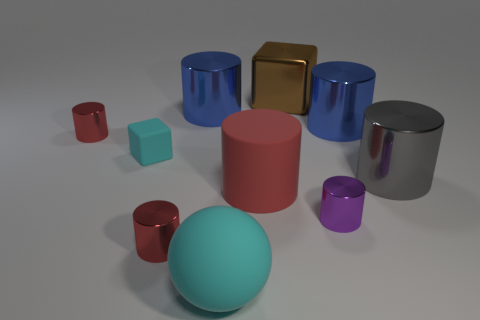There is a rubber cylinder; is its color the same as the tiny cylinder behind the big red thing?
Offer a terse response. Yes. There is a cube to the left of the big cyan object; does it have the same color as the big rubber ball?
Provide a succinct answer. Yes. The rubber sphere that is the same color as the small block is what size?
Make the answer very short. Large. Is the large ball the same color as the matte block?
Ensure brevity in your answer.  Yes. The rubber thing that is the same color as the small rubber block is what shape?
Your response must be concise. Sphere. There is a thing behind the large blue thing that is left of the purple thing; what is it made of?
Your response must be concise. Metal. Is the color of the tiny shiny object behind the gray metal thing the same as the matte thing that is on the right side of the large cyan matte thing?
Ensure brevity in your answer.  Yes. What is the color of the shiny cube?
Provide a succinct answer. Brown. Are there any other things that are the same color as the tiny cube?
Provide a succinct answer. Yes. There is a blue cylinder left of the sphere; does it have the same size as the small purple metallic cylinder?
Offer a terse response. No. 